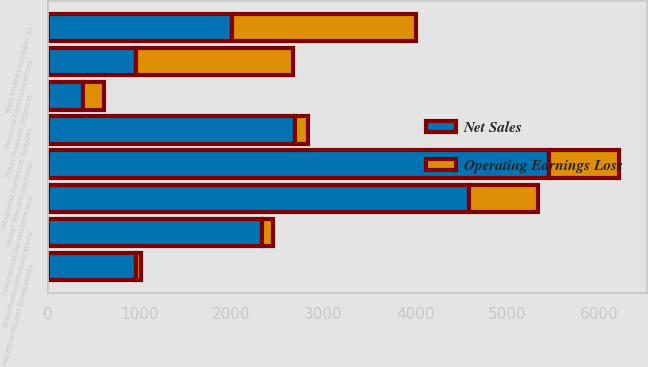Convert chart. <chart><loc_0><loc_0><loc_500><loc_500><stacked_bar_chart><ecel><fcel>Years Ended December 31<fcel>Personal Communications<fcel>Global Telecom Solutions<fcel>Commercial Government and<fcel>Integrated Electronic Systems<fcel>Broadband Communications<fcel>Other Products Segment<fcel>Adjustments and Eliminations<nl><fcel>Net Sales<fcel>2004<fcel>963<fcel>5457<fcel>4588<fcel>2696<fcel>2335<fcel>387<fcel>963<nl><fcel>Operating Earnings Loss<fcel>2004<fcel>1708<fcel>759<fcel>753<fcel>142<fcel>116<fcel>229<fcel>47<nl></chart> 